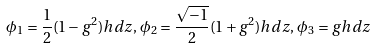Convert formula to latex. <formula><loc_0><loc_0><loc_500><loc_500>\phi _ { 1 } = \frac { 1 } { 2 } ( 1 - g ^ { 2 } ) h d z , \, \phi _ { 2 } = \frac { \sqrt { - 1 } } { 2 } ( 1 + g ^ { 2 } ) h d z , \, \phi _ { 3 } = g h d z</formula> 